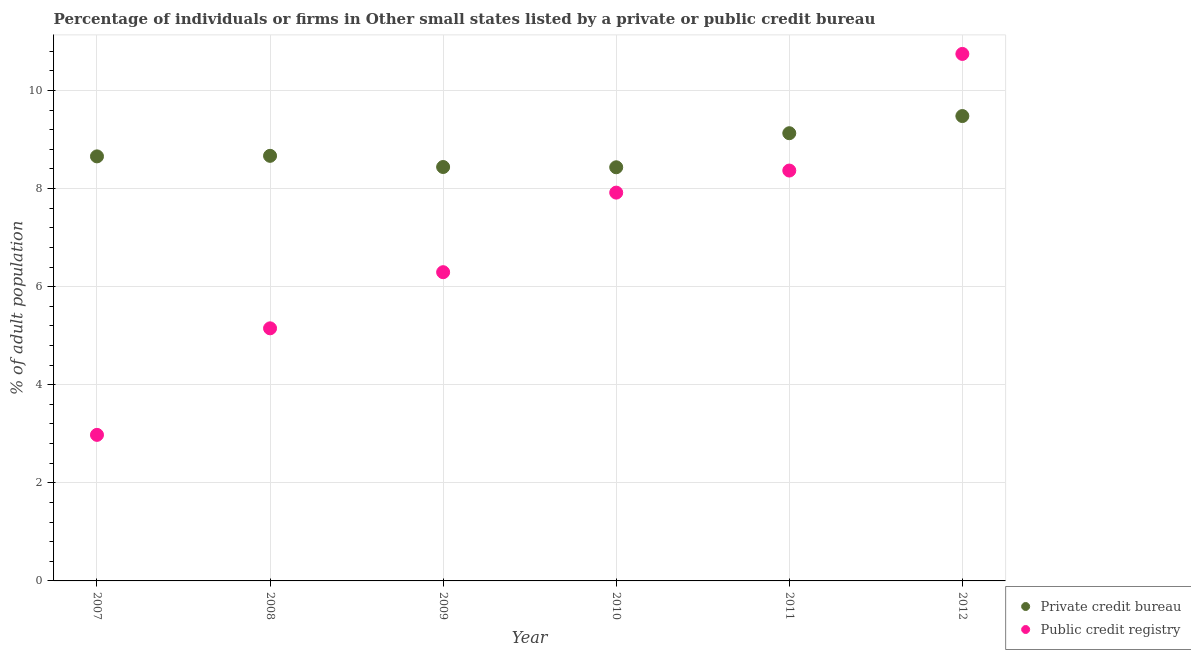Is the number of dotlines equal to the number of legend labels?
Offer a terse response. Yes. What is the percentage of firms listed by public credit bureau in 2011?
Give a very brief answer. 8.37. Across all years, what is the maximum percentage of firms listed by public credit bureau?
Provide a succinct answer. 10.74. Across all years, what is the minimum percentage of firms listed by public credit bureau?
Offer a terse response. 2.98. In which year was the percentage of firms listed by public credit bureau maximum?
Provide a short and direct response. 2012. In which year was the percentage of firms listed by public credit bureau minimum?
Make the answer very short. 2007. What is the total percentage of firms listed by public credit bureau in the graph?
Your response must be concise. 41.45. What is the difference between the percentage of firms listed by public credit bureau in 2011 and that in 2012?
Ensure brevity in your answer.  -2.38. What is the difference between the percentage of firms listed by public credit bureau in 2010 and the percentage of firms listed by private credit bureau in 2008?
Keep it short and to the point. -0.75. What is the average percentage of firms listed by private credit bureau per year?
Provide a succinct answer. 8.8. In the year 2009, what is the difference between the percentage of firms listed by private credit bureau and percentage of firms listed by public credit bureau?
Your response must be concise. 2.14. In how many years, is the percentage of firms listed by private credit bureau greater than 8.4 %?
Give a very brief answer. 6. What is the ratio of the percentage of firms listed by public credit bureau in 2007 to that in 2008?
Your answer should be compact. 0.58. What is the difference between the highest and the second highest percentage of firms listed by private credit bureau?
Your response must be concise. 0.35. What is the difference between the highest and the lowest percentage of firms listed by public credit bureau?
Provide a short and direct response. 7.77. Does the percentage of firms listed by public credit bureau monotonically increase over the years?
Ensure brevity in your answer.  Yes. Is the percentage of firms listed by private credit bureau strictly less than the percentage of firms listed by public credit bureau over the years?
Make the answer very short. No. How many years are there in the graph?
Provide a succinct answer. 6. What is the difference between two consecutive major ticks on the Y-axis?
Give a very brief answer. 2. Does the graph contain any zero values?
Offer a very short reply. No. Does the graph contain grids?
Offer a terse response. Yes. Where does the legend appear in the graph?
Your answer should be very brief. Bottom right. How many legend labels are there?
Offer a terse response. 2. How are the legend labels stacked?
Offer a terse response. Vertical. What is the title of the graph?
Provide a succinct answer. Percentage of individuals or firms in Other small states listed by a private or public credit bureau. What is the label or title of the X-axis?
Offer a terse response. Year. What is the label or title of the Y-axis?
Keep it short and to the point. % of adult population. What is the % of adult population in Private credit bureau in 2007?
Ensure brevity in your answer.  8.66. What is the % of adult population of Public credit registry in 2007?
Offer a very short reply. 2.98. What is the % of adult population of Private credit bureau in 2008?
Your response must be concise. 8.67. What is the % of adult population in Public credit registry in 2008?
Your response must be concise. 5.15. What is the % of adult population of Private credit bureau in 2009?
Make the answer very short. 8.44. What is the % of adult population in Public credit registry in 2009?
Give a very brief answer. 6.29. What is the % of adult population of Private credit bureau in 2010?
Keep it short and to the point. 8.43. What is the % of adult population of Public credit registry in 2010?
Make the answer very short. 7.92. What is the % of adult population of Private credit bureau in 2011?
Offer a very short reply. 9.13. What is the % of adult population of Public credit registry in 2011?
Your answer should be compact. 8.37. What is the % of adult population of Private credit bureau in 2012?
Provide a short and direct response. 9.48. What is the % of adult population in Public credit registry in 2012?
Your answer should be compact. 10.74. Across all years, what is the maximum % of adult population in Private credit bureau?
Provide a succinct answer. 9.48. Across all years, what is the maximum % of adult population in Public credit registry?
Provide a short and direct response. 10.74. Across all years, what is the minimum % of adult population in Private credit bureau?
Provide a short and direct response. 8.43. Across all years, what is the minimum % of adult population of Public credit registry?
Offer a terse response. 2.98. What is the total % of adult population of Private credit bureau in the graph?
Make the answer very short. 52.8. What is the total % of adult population of Public credit registry in the graph?
Ensure brevity in your answer.  41.45. What is the difference between the % of adult population of Private credit bureau in 2007 and that in 2008?
Keep it short and to the point. -0.01. What is the difference between the % of adult population in Public credit registry in 2007 and that in 2008?
Ensure brevity in your answer.  -2.17. What is the difference between the % of adult population of Private credit bureau in 2007 and that in 2009?
Offer a terse response. 0.22. What is the difference between the % of adult population in Public credit registry in 2007 and that in 2009?
Your answer should be compact. -3.32. What is the difference between the % of adult population of Private credit bureau in 2007 and that in 2010?
Your answer should be very brief. 0.22. What is the difference between the % of adult population of Public credit registry in 2007 and that in 2010?
Your answer should be compact. -4.94. What is the difference between the % of adult population in Private credit bureau in 2007 and that in 2011?
Your response must be concise. -0.47. What is the difference between the % of adult population of Public credit registry in 2007 and that in 2011?
Provide a short and direct response. -5.39. What is the difference between the % of adult population of Private credit bureau in 2007 and that in 2012?
Provide a succinct answer. -0.82. What is the difference between the % of adult population in Public credit registry in 2007 and that in 2012?
Provide a short and direct response. -7.77. What is the difference between the % of adult population of Private credit bureau in 2008 and that in 2009?
Offer a terse response. 0.23. What is the difference between the % of adult population in Public credit registry in 2008 and that in 2009?
Your response must be concise. -1.14. What is the difference between the % of adult population in Private credit bureau in 2008 and that in 2010?
Offer a terse response. 0.23. What is the difference between the % of adult population of Public credit registry in 2008 and that in 2010?
Your answer should be very brief. -2.77. What is the difference between the % of adult population of Private credit bureau in 2008 and that in 2011?
Offer a terse response. -0.46. What is the difference between the % of adult population of Public credit registry in 2008 and that in 2011?
Ensure brevity in your answer.  -3.22. What is the difference between the % of adult population of Private credit bureau in 2008 and that in 2012?
Provide a short and direct response. -0.81. What is the difference between the % of adult population of Public credit registry in 2008 and that in 2012?
Offer a terse response. -5.59. What is the difference between the % of adult population in Private credit bureau in 2009 and that in 2010?
Your response must be concise. 0.01. What is the difference between the % of adult population in Public credit registry in 2009 and that in 2010?
Offer a terse response. -1.62. What is the difference between the % of adult population in Private credit bureau in 2009 and that in 2011?
Keep it short and to the point. -0.69. What is the difference between the % of adult population in Public credit registry in 2009 and that in 2011?
Keep it short and to the point. -2.07. What is the difference between the % of adult population of Private credit bureau in 2009 and that in 2012?
Provide a short and direct response. -1.04. What is the difference between the % of adult population of Public credit registry in 2009 and that in 2012?
Make the answer very short. -4.45. What is the difference between the % of adult population in Private credit bureau in 2010 and that in 2011?
Offer a terse response. -0.69. What is the difference between the % of adult population in Public credit registry in 2010 and that in 2011?
Your answer should be very brief. -0.45. What is the difference between the % of adult population of Private credit bureau in 2010 and that in 2012?
Your response must be concise. -1.04. What is the difference between the % of adult population of Public credit registry in 2010 and that in 2012?
Offer a very short reply. -2.83. What is the difference between the % of adult population in Private credit bureau in 2011 and that in 2012?
Offer a very short reply. -0.35. What is the difference between the % of adult population in Public credit registry in 2011 and that in 2012?
Your response must be concise. -2.38. What is the difference between the % of adult population in Private credit bureau in 2007 and the % of adult population in Public credit registry in 2008?
Give a very brief answer. 3.51. What is the difference between the % of adult population in Private credit bureau in 2007 and the % of adult population in Public credit registry in 2009?
Offer a terse response. 2.36. What is the difference between the % of adult population in Private credit bureau in 2007 and the % of adult population in Public credit registry in 2010?
Offer a very short reply. 0.74. What is the difference between the % of adult population of Private credit bureau in 2007 and the % of adult population of Public credit registry in 2011?
Give a very brief answer. 0.29. What is the difference between the % of adult population of Private credit bureau in 2007 and the % of adult population of Public credit registry in 2012?
Provide a succinct answer. -2.09. What is the difference between the % of adult population in Private credit bureau in 2008 and the % of adult population in Public credit registry in 2009?
Offer a terse response. 2.37. What is the difference between the % of adult population in Private credit bureau in 2008 and the % of adult population in Public credit registry in 2010?
Your response must be concise. 0.75. What is the difference between the % of adult population in Private credit bureau in 2008 and the % of adult population in Public credit registry in 2011?
Ensure brevity in your answer.  0.3. What is the difference between the % of adult population of Private credit bureau in 2008 and the % of adult population of Public credit registry in 2012?
Your response must be concise. -2.08. What is the difference between the % of adult population of Private credit bureau in 2009 and the % of adult population of Public credit registry in 2010?
Give a very brief answer. 0.52. What is the difference between the % of adult population in Private credit bureau in 2009 and the % of adult population in Public credit registry in 2011?
Make the answer very short. 0.07. What is the difference between the % of adult population in Private credit bureau in 2009 and the % of adult population in Public credit registry in 2012?
Your answer should be very brief. -2.31. What is the difference between the % of adult population of Private credit bureau in 2010 and the % of adult population of Public credit registry in 2011?
Make the answer very short. 0.07. What is the difference between the % of adult population in Private credit bureau in 2010 and the % of adult population in Public credit registry in 2012?
Ensure brevity in your answer.  -2.31. What is the difference between the % of adult population in Private credit bureau in 2011 and the % of adult population in Public credit registry in 2012?
Your answer should be very brief. -1.62. What is the average % of adult population in Public credit registry per year?
Ensure brevity in your answer.  6.91. In the year 2007, what is the difference between the % of adult population of Private credit bureau and % of adult population of Public credit registry?
Ensure brevity in your answer.  5.68. In the year 2008, what is the difference between the % of adult population of Private credit bureau and % of adult population of Public credit registry?
Your response must be concise. 3.52. In the year 2009, what is the difference between the % of adult population in Private credit bureau and % of adult population in Public credit registry?
Provide a succinct answer. 2.14. In the year 2010, what is the difference between the % of adult population in Private credit bureau and % of adult population in Public credit registry?
Ensure brevity in your answer.  0.52. In the year 2011, what is the difference between the % of adult population in Private credit bureau and % of adult population in Public credit registry?
Offer a very short reply. 0.76. In the year 2012, what is the difference between the % of adult population of Private credit bureau and % of adult population of Public credit registry?
Give a very brief answer. -1.27. What is the ratio of the % of adult population in Private credit bureau in 2007 to that in 2008?
Offer a very short reply. 1. What is the ratio of the % of adult population of Public credit registry in 2007 to that in 2008?
Your answer should be compact. 0.58. What is the ratio of the % of adult population of Private credit bureau in 2007 to that in 2009?
Provide a succinct answer. 1.03. What is the ratio of the % of adult population of Public credit registry in 2007 to that in 2009?
Provide a short and direct response. 0.47. What is the ratio of the % of adult population in Private credit bureau in 2007 to that in 2010?
Your answer should be compact. 1.03. What is the ratio of the % of adult population in Public credit registry in 2007 to that in 2010?
Your response must be concise. 0.38. What is the ratio of the % of adult population of Private credit bureau in 2007 to that in 2011?
Your answer should be compact. 0.95. What is the ratio of the % of adult population in Public credit registry in 2007 to that in 2011?
Your response must be concise. 0.36. What is the ratio of the % of adult population of Private credit bureau in 2007 to that in 2012?
Provide a succinct answer. 0.91. What is the ratio of the % of adult population in Public credit registry in 2007 to that in 2012?
Offer a terse response. 0.28. What is the ratio of the % of adult population in Private credit bureau in 2008 to that in 2009?
Offer a very short reply. 1.03. What is the ratio of the % of adult population in Public credit registry in 2008 to that in 2009?
Keep it short and to the point. 0.82. What is the ratio of the % of adult population in Private credit bureau in 2008 to that in 2010?
Your answer should be compact. 1.03. What is the ratio of the % of adult population of Public credit registry in 2008 to that in 2010?
Your response must be concise. 0.65. What is the ratio of the % of adult population in Private credit bureau in 2008 to that in 2011?
Your answer should be very brief. 0.95. What is the ratio of the % of adult population of Public credit registry in 2008 to that in 2011?
Give a very brief answer. 0.62. What is the ratio of the % of adult population in Private credit bureau in 2008 to that in 2012?
Offer a terse response. 0.91. What is the ratio of the % of adult population in Public credit registry in 2008 to that in 2012?
Provide a succinct answer. 0.48. What is the ratio of the % of adult population in Public credit registry in 2009 to that in 2010?
Your answer should be compact. 0.8. What is the ratio of the % of adult population of Private credit bureau in 2009 to that in 2011?
Offer a terse response. 0.92. What is the ratio of the % of adult population of Public credit registry in 2009 to that in 2011?
Your answer should be very brief. 0.75. What is the ratio of the % of adult population of Private credit bureau in 2009 to that in 2012?
Give a very brief answer. 0.89. What is the ratio of the % of adult population of Public credit registry in 2009 to that in 2012?
Provide a succinct answer. 0.59. What is the ratio of the % of adult population of Private credit bureau in 2010 to that in 2011?
Provide a short and direct response. 0.92. What is the ratio of the % of adult population in Public credit registry in 2010 to that in 2011?
Your answer should be very brief. 0.95. What is the ratio of the % of adult population of Private credit bureau in 2010 to that in 2012?
Provide a short and direct response. 0.89. What is the ratio of the % of adult population in Public credit registry in 2010 to that in 2012?
Provide a succinct answer. 0.74. What is the ratio of the % of adult population in Private credit bureau in 2011 to that in 2012?
Offer a very short reply. 0.96. What is the ratio of the % of adult population of Public credit registry in 2011 to that in 2012?
Your answer should be very brief. 0.78. What is the difference between the highest and the second highest % of adult population in Public credit registry?
Make the answer very short. 2.38. What is the difference between the highest and the lowest % of adult population in Private credit bureau?
Offer a very short reply. 1.04. What is the difference between the highest and the lowest % of adult population of Public credit registry?
Offer a terse response. 7.77. 